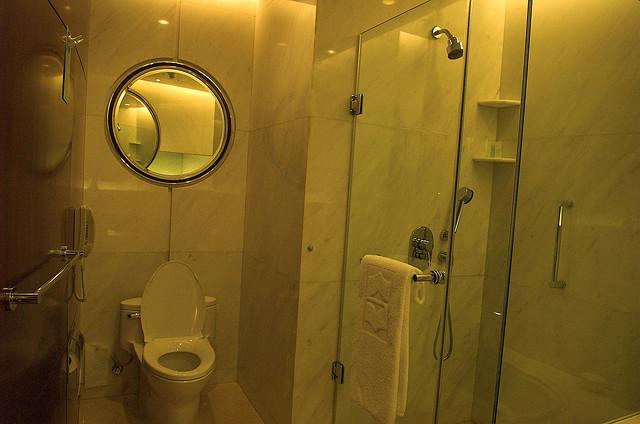Where is the mirror?
Quick response, please. Above toilet. Is the toilets lid up or down?
Answer briefly. Up. What material is the shower door made of?
Short answer required. Glass. 